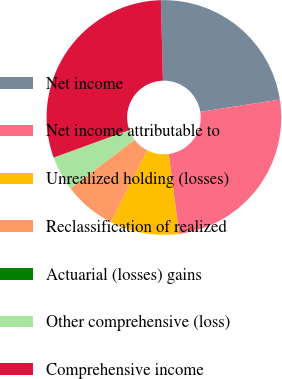Convert chart to OTSL. <chart><loc_0><loc_0><loc_500><loc_500><pie_chart><fcel>Net income<fcel>Net income attributable to<fcel>Unrealized holding (losses)<fcel>Reclassification of realized<fcel>Actuarial (losses) gains<fcel>Other comprehensive (loss)<fcel>Comprehensive income<nl><fcel>22.98%<fcel>25.37%<fcel>9.56%<fcel>7.17%<fcel>0.01%<fcel>4.78%<fcel>30.14%<nl></chart> 